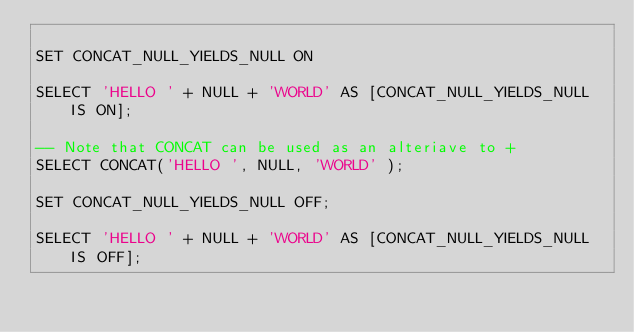Convert code to text. <code><loc_0><loc_0><loc_500><loc_500><_SQL_>
SET CONCAT_NULL_YIELDS_NULL ON

SELECT 'HELLO ' + NULL + 'WORLD' AS [CONCAT_NULL_YIELDS_NULL IS ON];

-- Note that CONCAT can be used as an alteriave to +
SELECT CONCAT('HELLO ', NULL, 'WORLD' );

SET CONCAT_NULL_YIELDS_NULL OFF;

SELECT 'HELLO ' + NULL + 'WORLD' AS [CONCAT_NULL_YIELDS_NULL IS OFF];</code> 